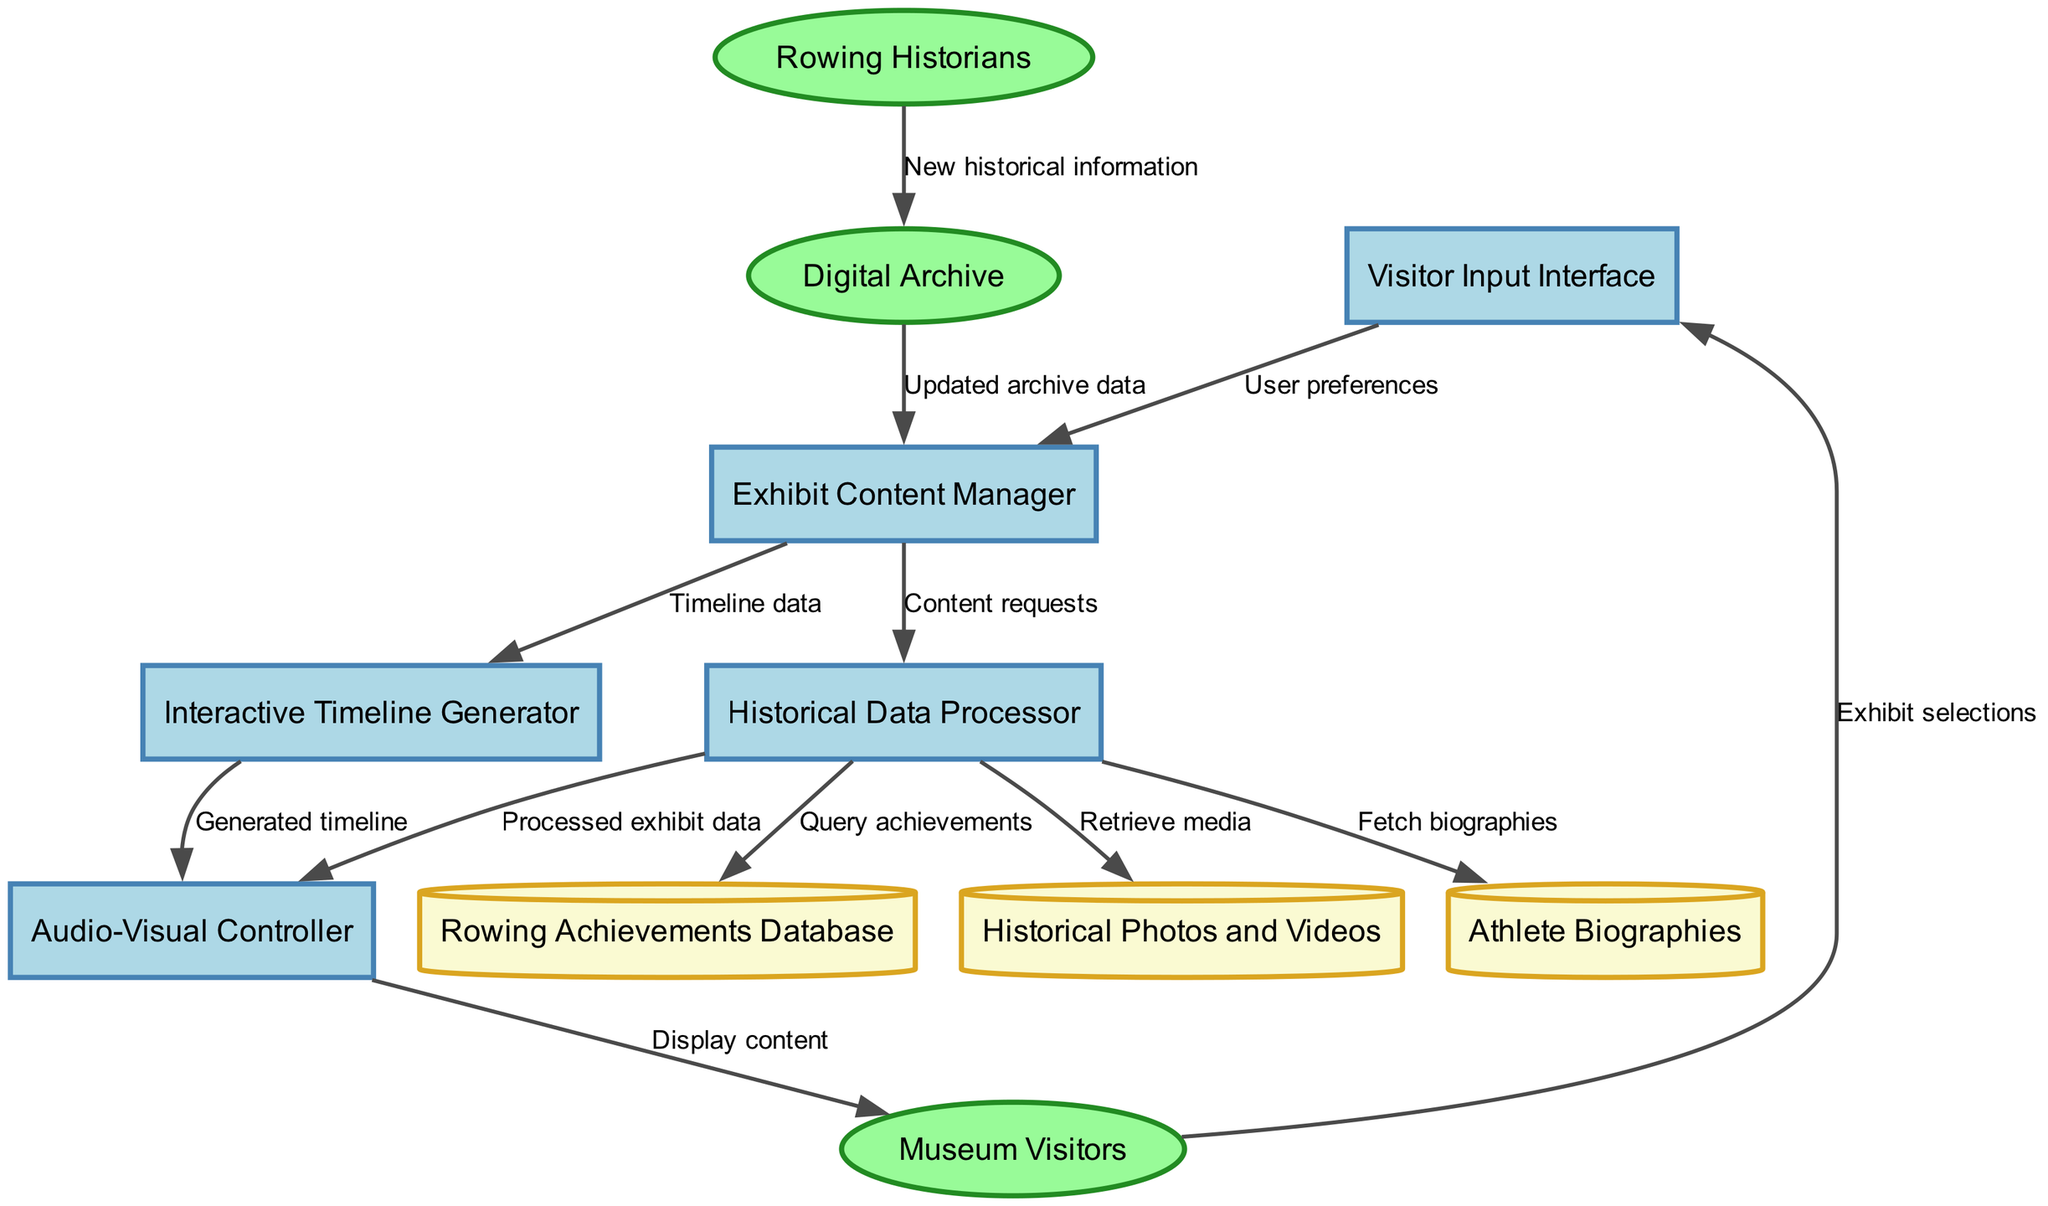What are the data stores in the diagram? The data stores include "Rowing Achievements Database", "Historical Photos and Videos", and "Athlete Biographies". These are the nodes represented in cylindrical shapes according to the diagram conventions.
Answer: Rowing Achievements Database, Historical Photos and Videos, Athlete Biographies How many external entities are represented? The external entities consist of "Museum Visitors", "Rowing Historians", and "Digital Archive", which are represented as ellipses in the diagram. Therefore, there are three external entities.
Answer: 3 What flow originates from "Museum Visitors"? The flow labeled "Exhibit selections" originates from "Museum Visitors" and connects to the "Visitor Input Interface". This is evident as it directly connects the two nodes specified.
Answer: Exhibit selections What is the purpose of the "Historical Data Processor"? The "Historical Data Processor" is responsible for processing requested content, querying the "Rowing Achievements Database", retrieving from "Historical Photos and Videos", fetching from "Athlete Biographies", and sending the processed data to the "Audio-Visual Controller". Its purpose is to handle all incoming data requests from "Exhibit Content Manager".
Answer: Process exhibit data Which process generates the timeline? The "Interactive Timeline Generator" is the process that generates the timeline data and sends it to the "Audio-Visual Controller". This is confirmed by observing the data flow labeled "Generated timeline" leading from the "Interactive Timeline Generator" to the "Audio-Visual Controller".
Answer: Interactive Timeline Generator How do rowing historians contribute to the system? Rowing Historians input new historical information into the "Digital Archive", which is then updated in the "Exhibit Content Manager". This interaction is established through the data flow "New historical information" connecting "Rowing Historians" to the "Digital Archive".
Answer: New historical information What type of data flows to the "Audio-Visual Controller"? The "Audio-Visual Controller" receives both "Processed exhibit data" from the "Historical Data Processor" and "Generated timeline" from the "Interactive Timeline Generator". This indicates that the controller is intended to display various multimedia content including processed data specific to the exhibits and timelines.
Answer: Processed exhibit data, Generated timeline Which two entities are involved in updating the archive data? The "Rowing Historians" provide "New historical information" to the "Digital Archive", which is then received by the "Exhibit Content Manager" as "Updated archive data". This flow demonstrates how contributions by historians are incorporated into the exhibit system through the digital archive update process.
Answer: Rowing Historians, Digital Archive 